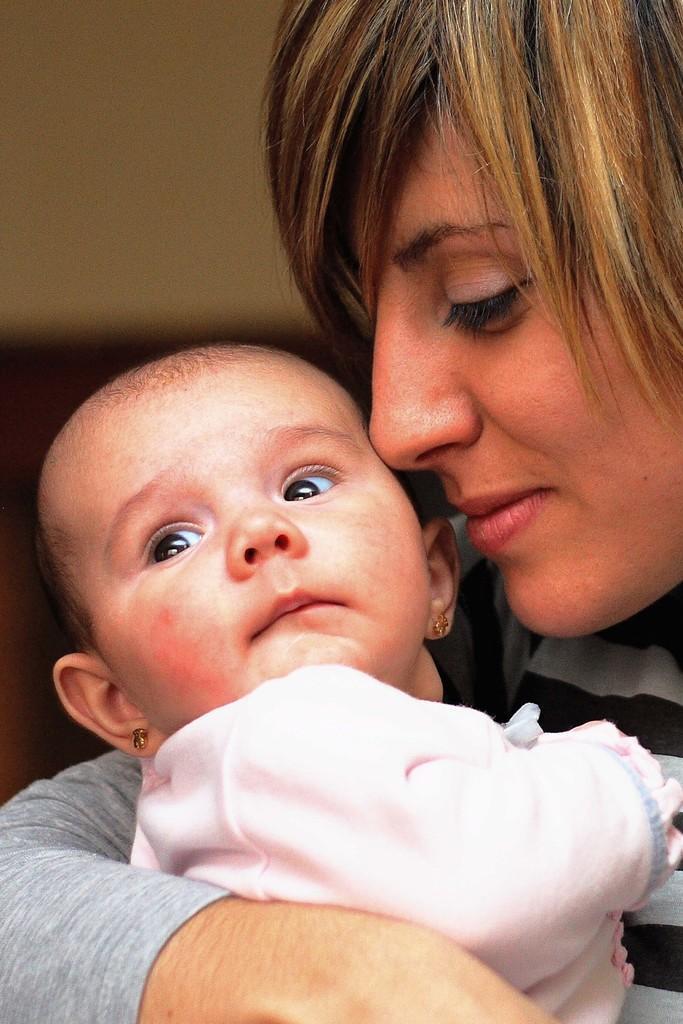In one or two sentences, can you explain what this image depicts? A woman is holding the baby, both of them wore dresses. 